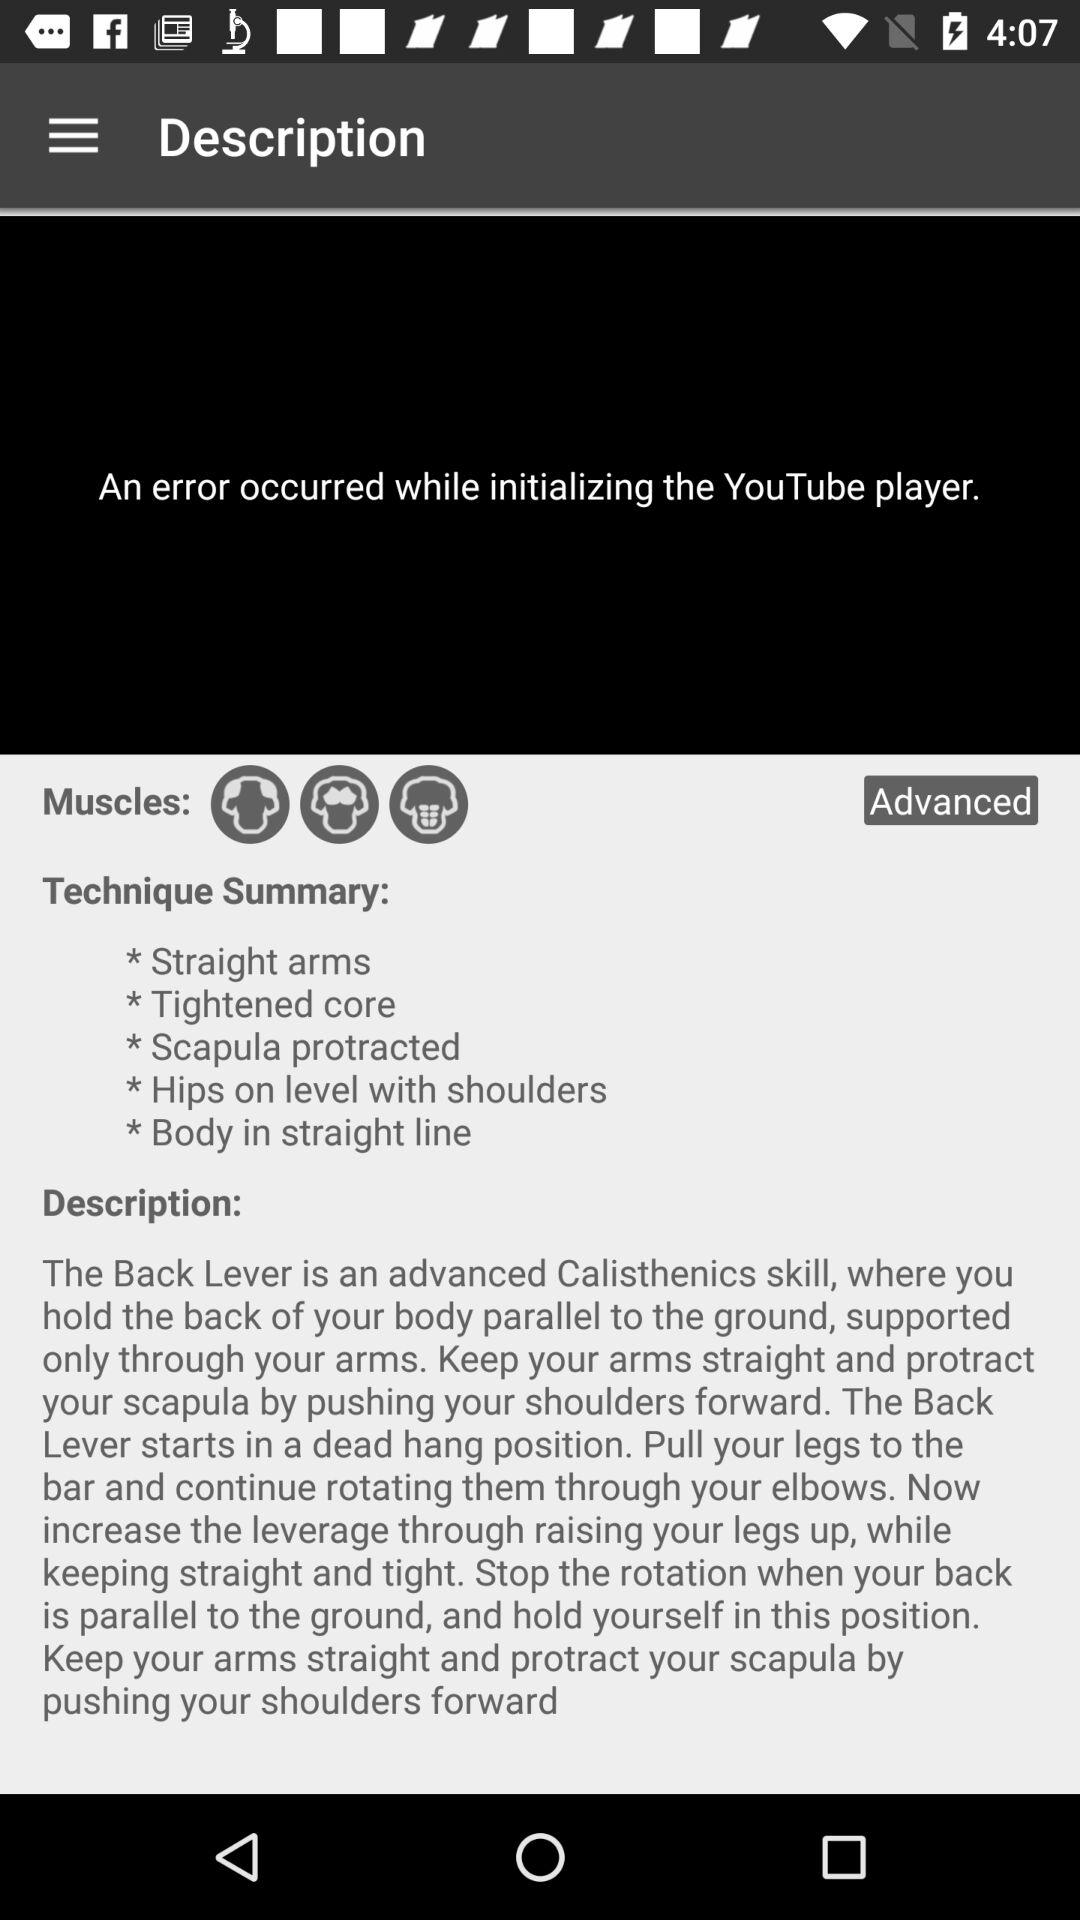How many steps are in the technique summary?
Answer the question using a single word or phrase. 5 